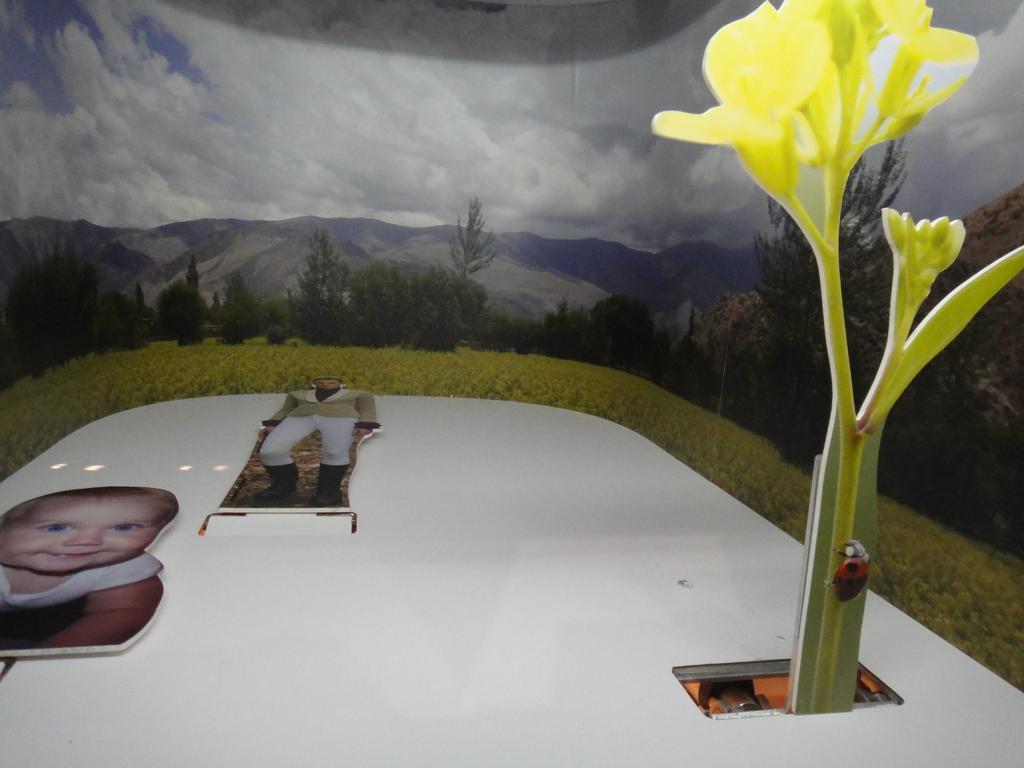Describe this image in one or two sentences. In this picture I can see a table, these are looking like boards on the table, and in the background this is looking like a wall poster. 